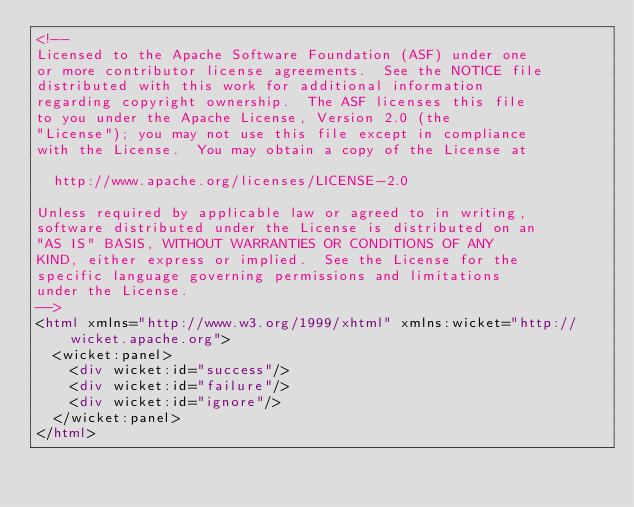Convert code to text. <code><loc_0><loc_0><loc_500><loc_500><_HTML_><!--
Licensed to the Apache Software Foundation (ASF) under one
or more contributor license agreements.  See the NOTICE file
distributed with this work for additional information
regarding copyright ownership.  The ASF licenses this file
to you under the Apache License, Version 2.0 (the
"License"); you may not use this file except in compliance
with the License.  You may obtain a copy of the License at

  http://www.apache.org/licenses/LICENSE-2.0

Unless required by applicable law or agreed to in writing,
software distributed under the License is distributed on an
"AS IS" BASIS, WITHOUT WARRANTIES OR CONDITIONS OF ANY
KIND, either express or implied.  See the License for the
specific language governing permissions and limitations
under the License.
-->
<html xmlns="http://www.w3.org/1999/xhtml" xmlns:wicket="http://wicket.apache.org">
  <wicket:panel>
    <div wicket:id="success"/>
    <div wicket:id="failure"/>
    <div wicket:id="ignore"/>
  </wicket:panel>
</html>
</code> 